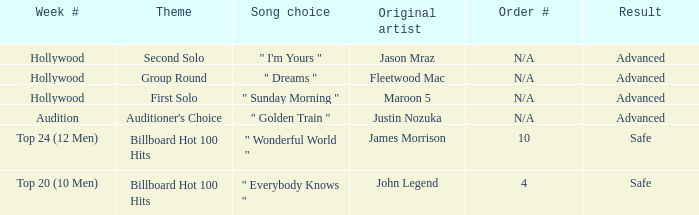What are all of the order # where authentic artist is maroon 5 N/A. 